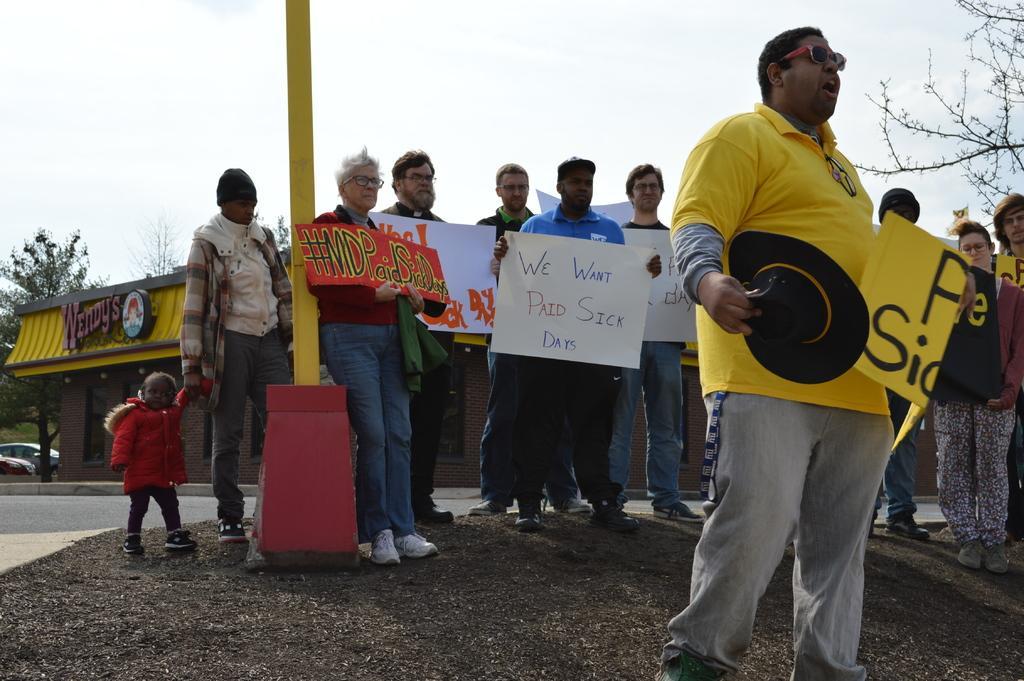Could you give a brief overview of what you see in this image? In this picture we can see a few people holding posters in their hands. We can see a building, tree, vehicle and a pole is visible on the path. 